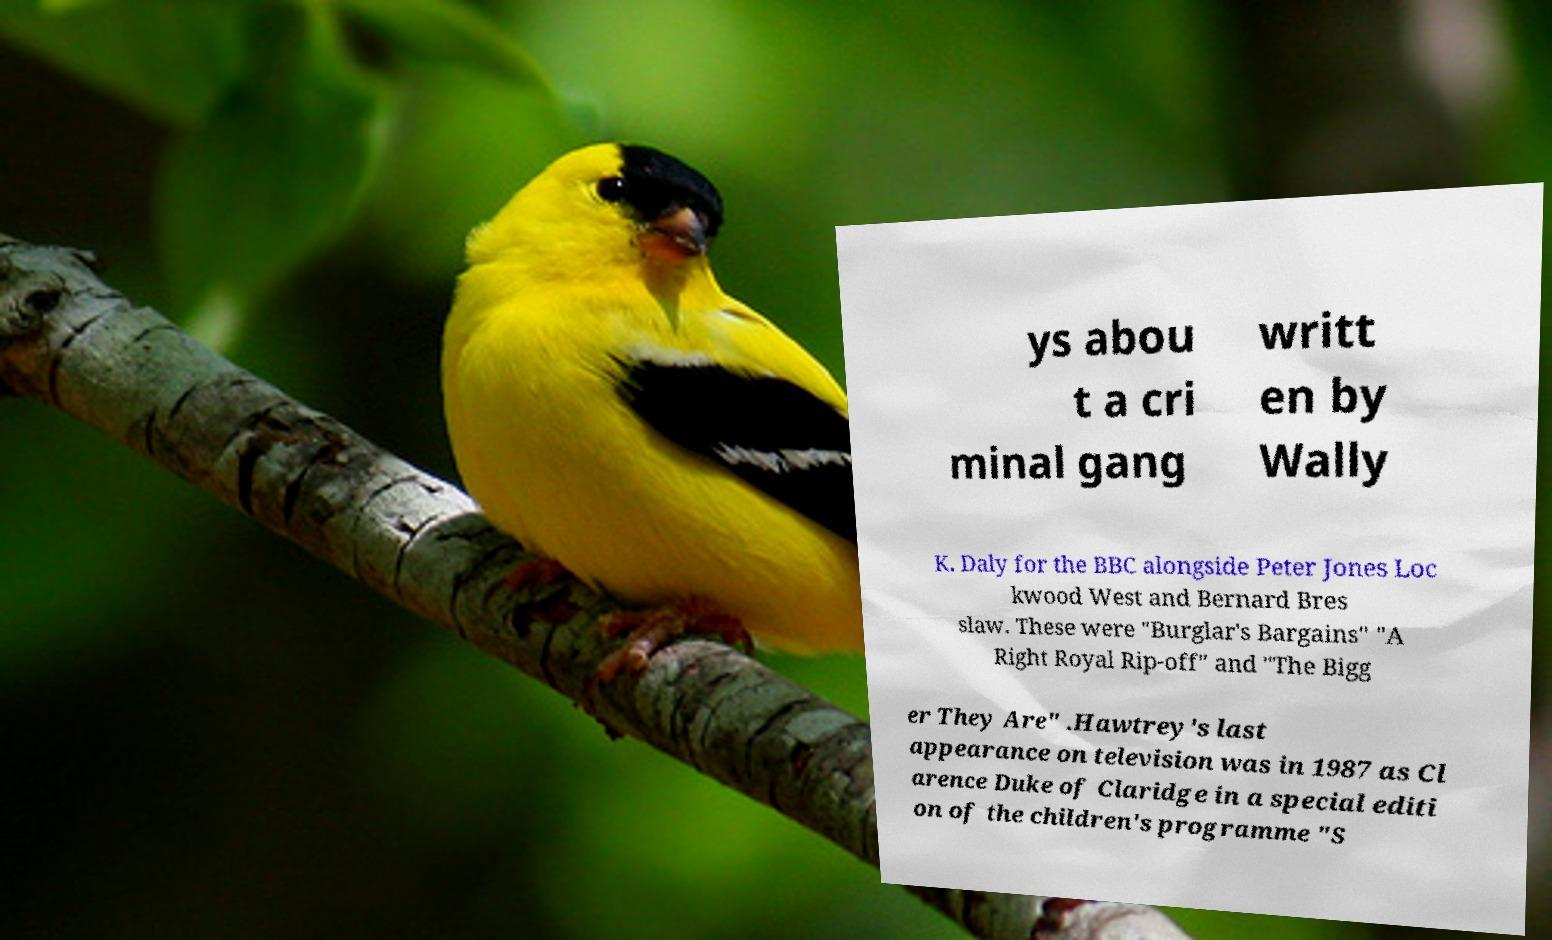Can you accurately transcribe the text from the provided image for me? ys abou t a cri minal gang writt en by Wally K. Daly for the BBC alongside Peter Jones Loc kwood West and Bernard Bres slaw. These were "Burglar's Bargains" "A Right Royal Rip-off" and "The Bigg er They Are" .Hawtrey's last appearance on television was in 1987 as Cl arence Duke of Claridge in a special editi on of the children's programme "S 